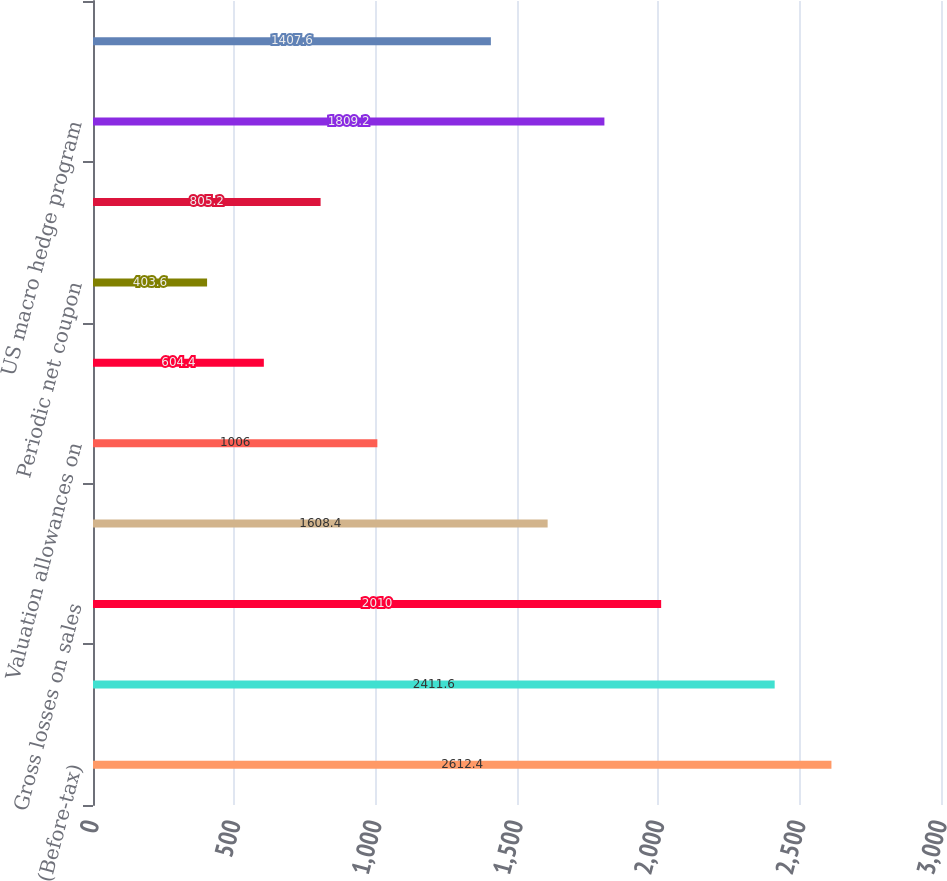Convert chart. <chart><loc_0><loc_0><loc_500><loc_500><bar_chart><fcel>(Before-tax)<fcel>Gross gains on sales<fcel>Gross losses on sales<fcel>Net OTTI losses recognized in<fcel>Valuation allowances on<fcel>Japanese fixed annuity<fcel>Periodic net coupon<fcel>GMWB derivatives net<fcel>US macro hedge program<fcel>Total US program<nl><fcel>2612.4<fcel>2411.6<fcel>2010<fcel>1608.4<fcel>1006<fcel>604.4<fcel>403.6<fcel>805.2<fcel>1809.2<fcel>1407.6<nl></chart> 